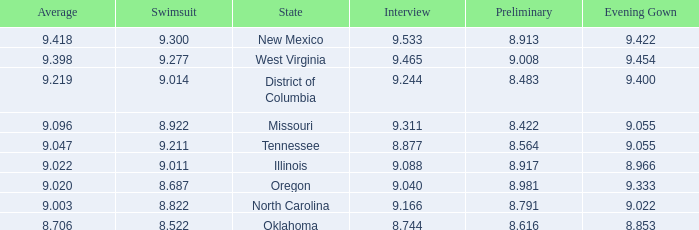Name the preliminary for north carolina 8.791. Can you parse all the data within this table? {'header': ['Average', 'Swimsuit', 'State', 'Interview', 'Preliminary', 'Evening Gown'], 'rows': [['9.418', '9.300', 'New Mexico', '9.533', '8.913', '9.422'], ['9.398', '9.277', 'West Virginia', '9.465', '9.008', '9.454'], ['9.219', '9.014', 'District of Columbia', '9.244', '8.483', '9.400'], ['9.096', '8.922', 'Missouri', '9.311', '8.422', '9.055'], ['9.047', '9.211', 'Tennessee', '8.877', '8.564', '9.055'], ['9.022', '9.011', 'Illinois', '9.088', '8.917', '8.966'], ['9.020', '8.687', 'Oregon', '9.040', '8.981', '9.333'], ['9.003', '8.822', 'North Carolina', '9.166', '8.791', '9.022'], ['8.706', '8.522', 'Oklahoma', '8.744', '8.616', '8.853']]} 